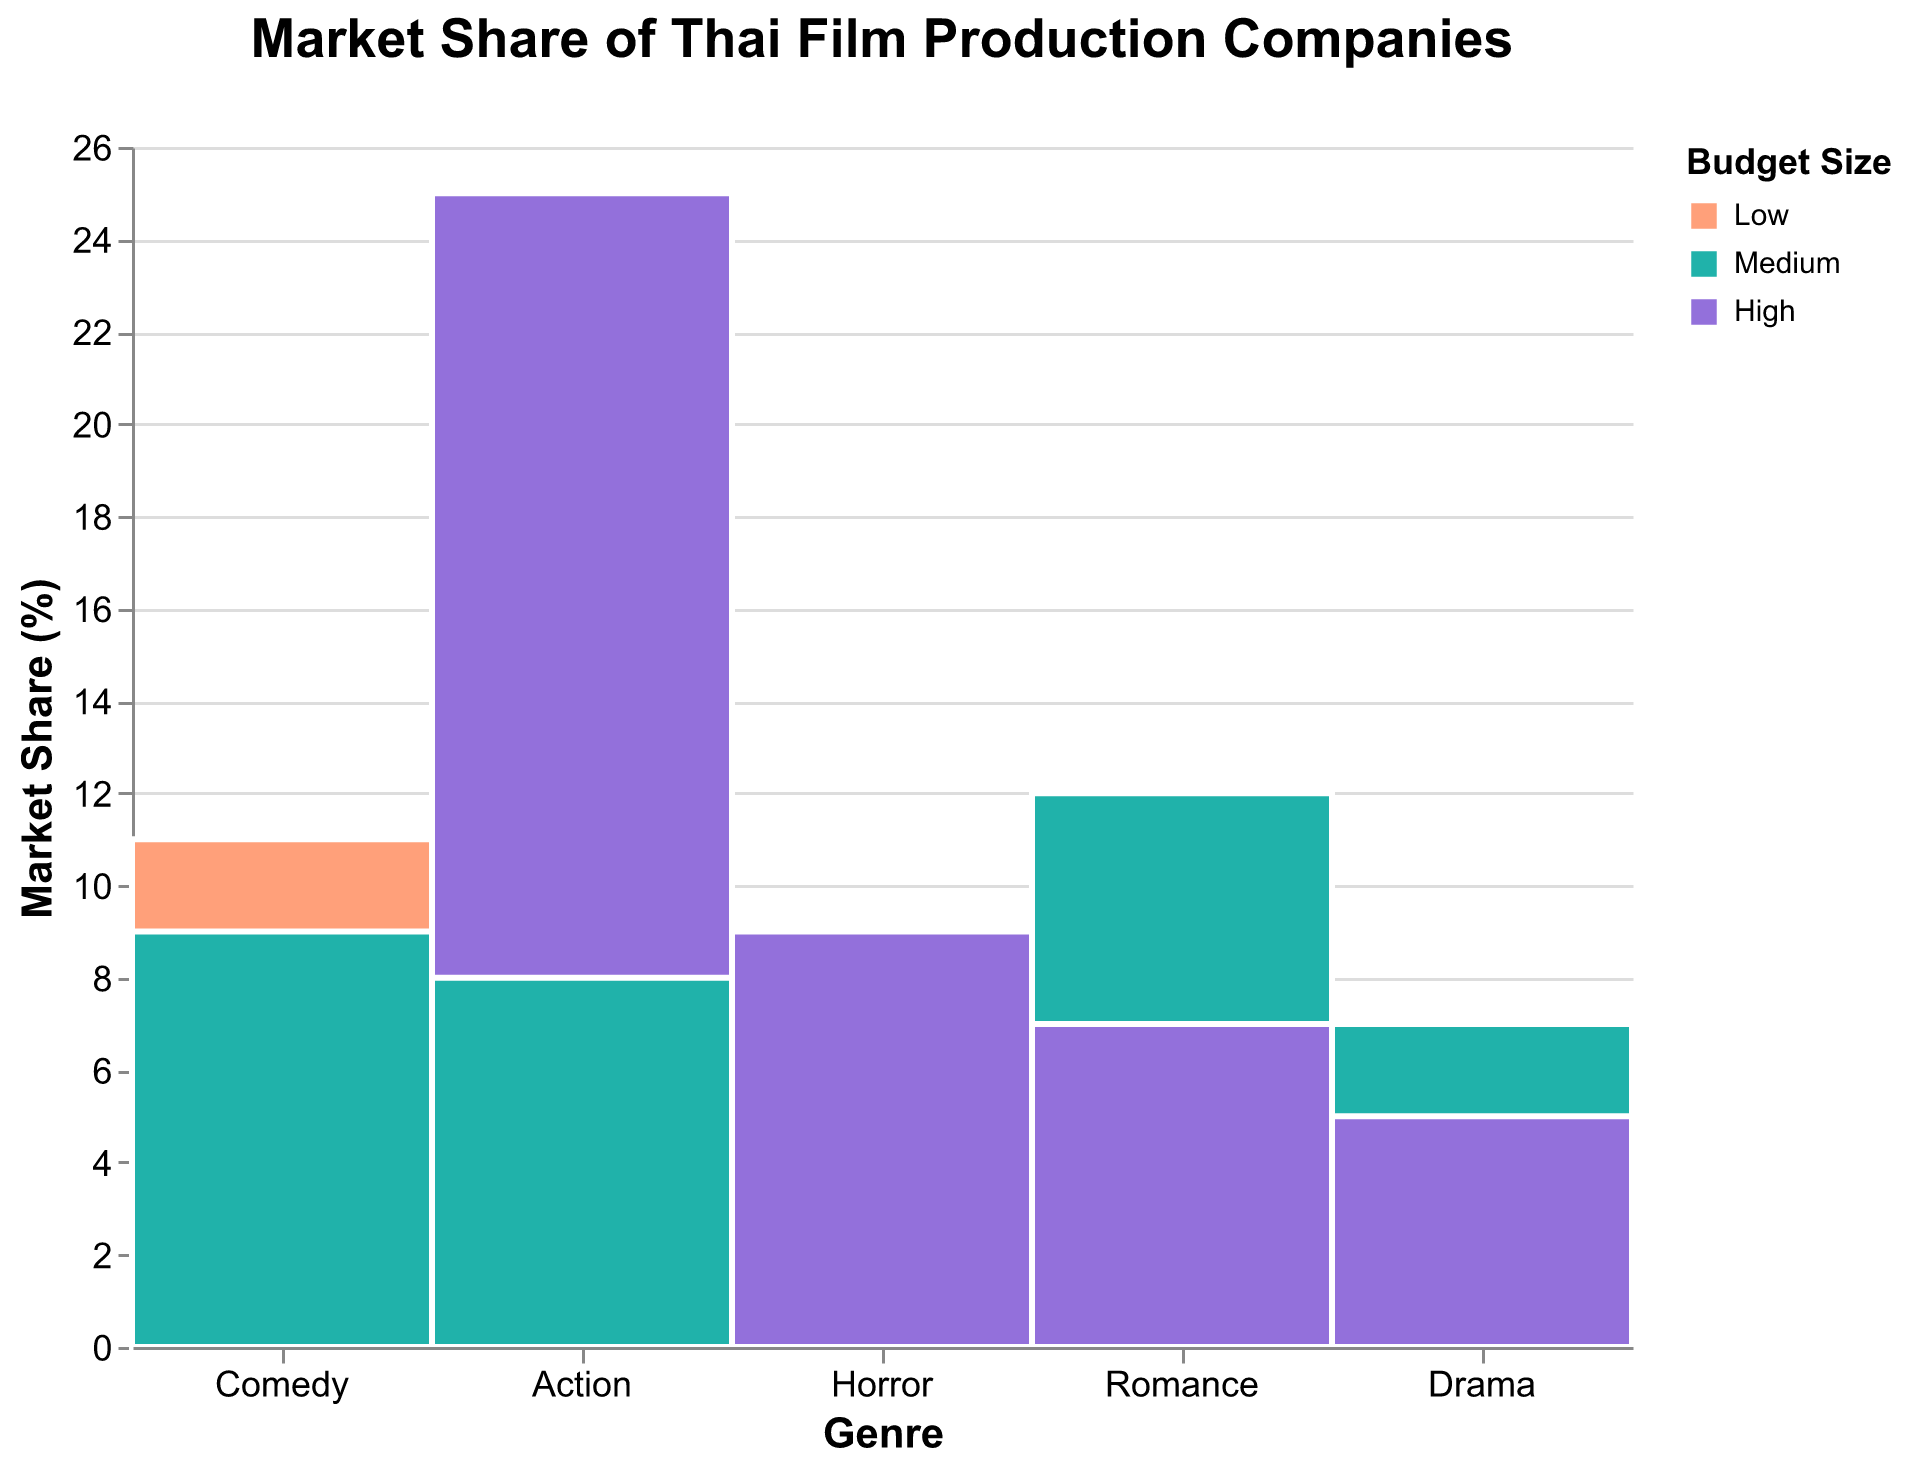What's the title of the figure? The title of the figure is located at the top and provides a summary of what the figure represents.
Answer: Market Share of Thai Film Production Companies How many genres are represented in the figure? The genres are displayed along the x-axis of the figure. Counting each unique label will give the number of genres.
Answer: 5 Which budget size has the largest representation in the "Action" genre? Look at the "Action" genre on the x-axis and observe which of the color segments is the largest for that bar.
Answer: High What's the market share percentage of high-budget horror films? Hover over the "Horror" genre with "High" budget which is shown in purple. The tooltip will display the market share percentage.
Answer: 9% Which genre has the smallest overall market share? Compare the total height of bars for each genre on the y-axis to determine which one is shortest.
Answer: Drama Which comedy production company's market share is depicted in the "Medium" budget size? By looking at the Comedy genre and the segment colored with the medium budget color, you can identify the company using the data table.
Answer: Workpoint Entertainment What percentage of the market share does the "Romance" genre with "Medium" budget size hold? Find the "Romance" genre on the x-axis and look for the medium budget size color (light green). Hover over it to see the percentage.
Answer: 12% Which genre has the highest market share for the "Low" budget size? Identify the largest segment colored for "Low" budget size (orange) and see which genre it corresponds to.
Answer: Comedy How does the market share of "High" budget drama films compare to "High" budget romance films? Compare the heights of the high budget segments for "Drama" (purple) and "Romance" (purple) genres.
Answer: Romance is higher What is the combined market share percentage for high-budget films across all genres? Add the percentages of high-budget segments (purple) from each genre: Action + Romance + Drama + Horror => 15% + 7% + 5% + 9% = 36%
Answer: 36% 